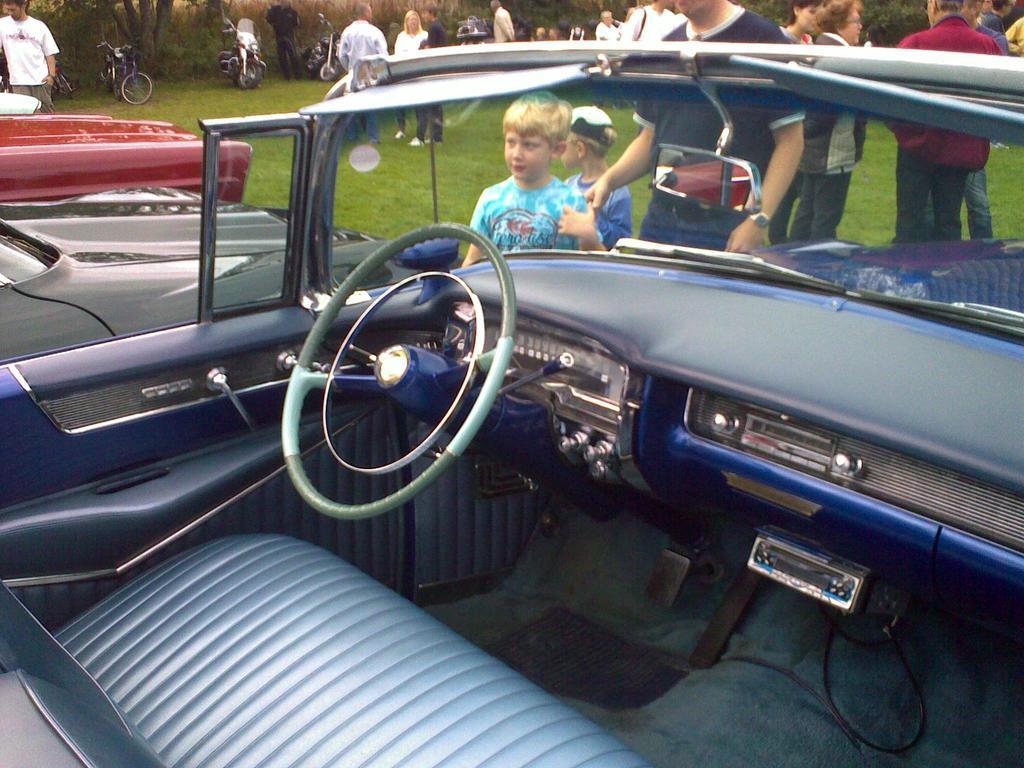Describe this image in one or two sentences. In the picture we can see inside the car with steering, seat, break and from the windshield of the car we can see some people are standing on the grass surface and beside the car we can see two other cars and in the background we can see the motorcycles, bicycles and trees. 